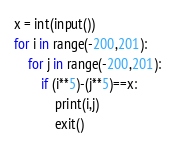<code> <loc_0><loc_0><loc_500><loc_500><_Python_>x = int(input())
for i in range(-200,201):
    for j in range(-200,201):
        if (i**5)-(j**5)==x:
            print(i,j)
            exit()
</code> 